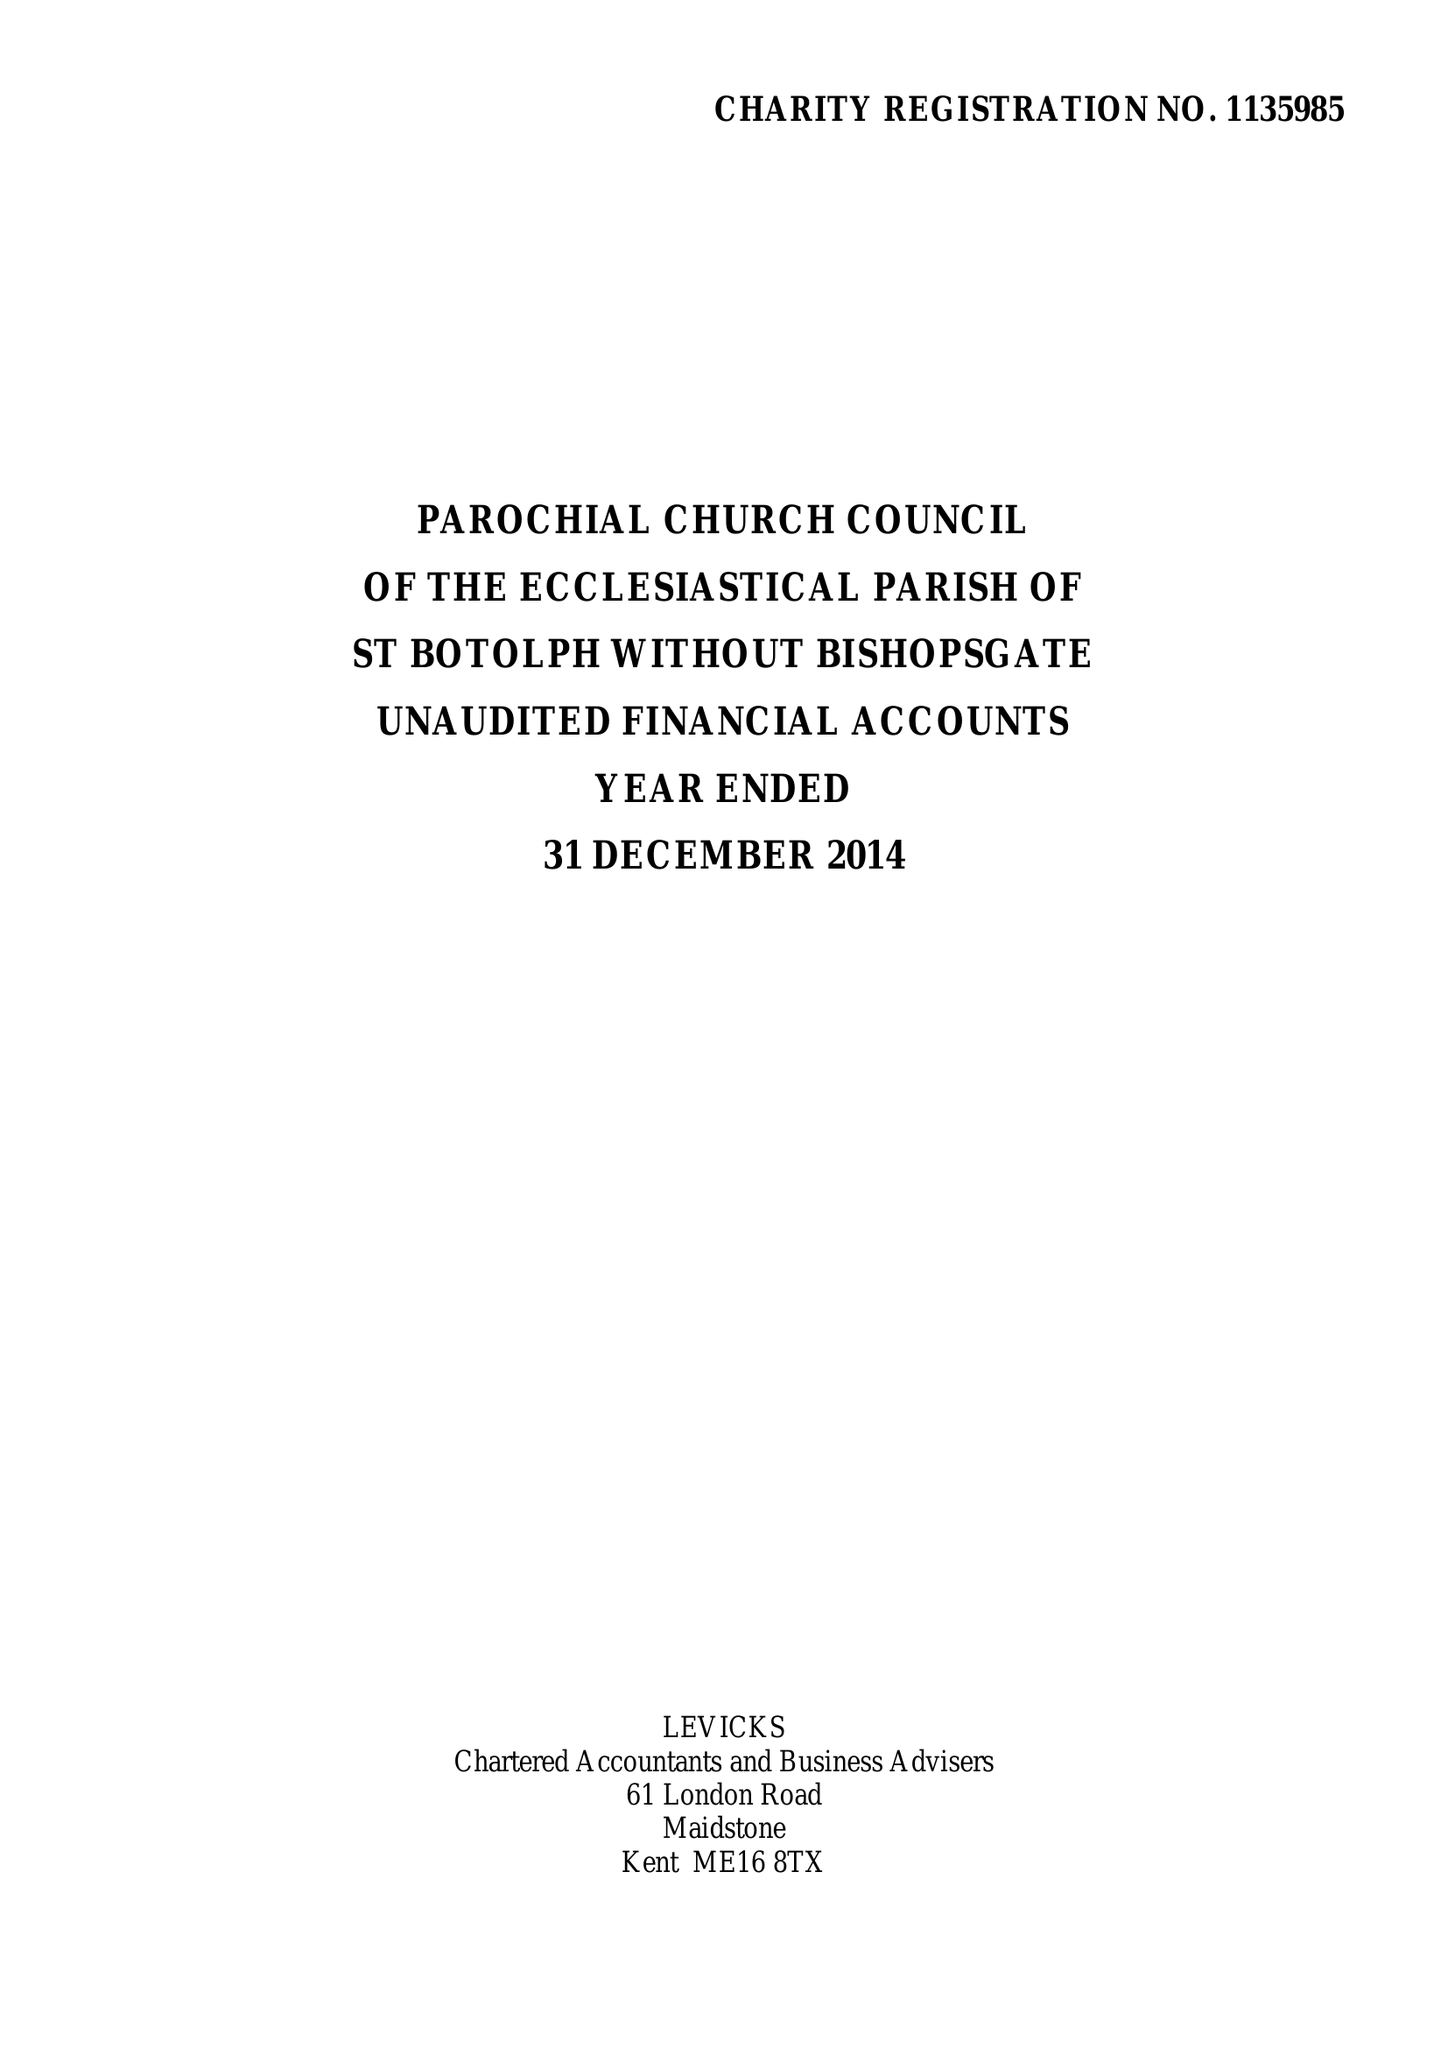What is the value for the report_date?
Answer the question using a single word or phrase. 2014-12-31 